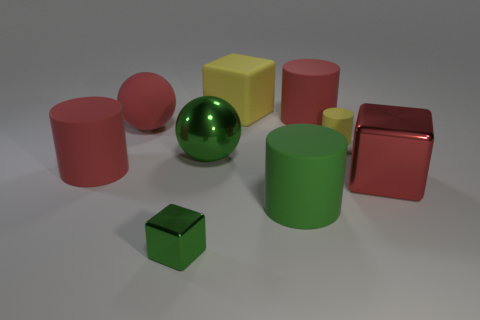Subtract 1 cylinders. How many cylinders are left? 3 Subtract all cyan cylinders. Subtract all blue blocks. How many cylinders are left? 4 Subtract all balls. How many objects are left? 7 Add 3 small metallic blocks. How many small metallic blocks are left? 4 Add 3 tiny green metallic things. How many tiny green metallic things exist? 4 Subtract 0 purple cylinders. How many objects are left? 9 Subtract all big cyan rubber cylinders. Subtract all blocks. How many objects are left? 6 